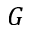<formula> <loc_0><loc_0><loc_500><loc_500>G</formula> 